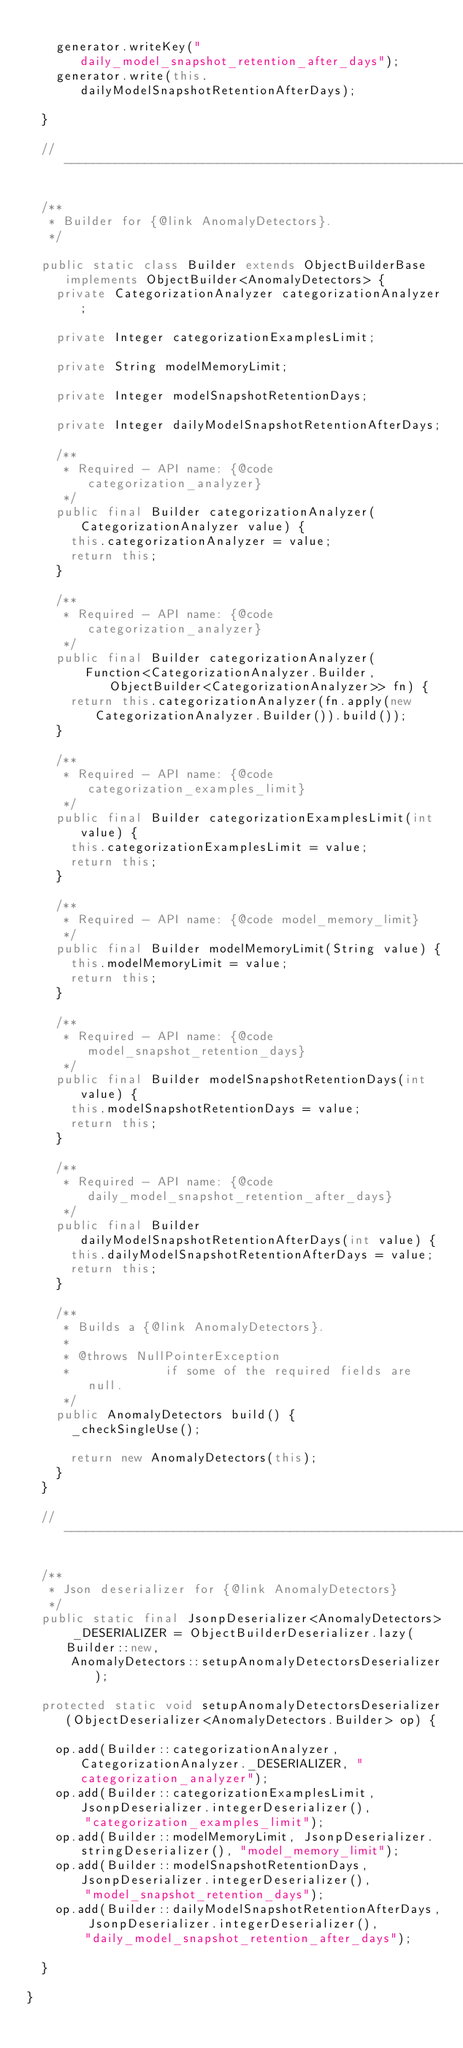<code> <loc_0><loc_0><loc_500><loc_500><_Java_>
		generator.writeKey("daily_model_snapshot_retention_after_days");
		generator.write(this.dailyModelSnapshotRetentionAfterDays);

	}

	// ---------------------------------------------------------------------------------------------

	/**
	 * Builder for {@link AnomalyDetectors}.
	 */

	public static class Builder extends ObjectBuilderBase implements ObjectBuilder<AnomalyDetectors> {
		private CategorizationAnalyzer categorizationAnalyzer;

		private Integer categorizationExamplesLimit;

		private String modelMemoryLimit;

		private Integer modelSnapshotRetentionDays;

		private Integer dailyModelSnapshotRetentionAfterDays;

		/**
		 * Required - API name: {@code categorization_analyzer}
		 */
		public final Builder categorizationAnalyzer(CategorizationAnalyzer value) {
			this.categorizationAnalyzer = value;
			return this;
		}

		/**
		 * Required - API name: {@code categorization_analyzer}
		 */
		public final Builder categorizationAnalyzer(
				Function<CategorizationAnalyzer.Builder, ObjectBuilder<CategorizationAnalyzer>> fn) {
			return this.categorizationAnalyzer(fn.apply(new CategorizationAnalyzer.Builder()).build());
		}

		/**
		 * Required - API name: {@code categorization_examples_limit}
		 */
		public final Builder categorizationExamplesLimit(int value) {
			this.categorizationExamplesLimit = value;
			return this;
		}

		/**
		 * Required - API name: {@code model_memory_limit}
		 */
		public final Builder modelMemoryLimit(String value) {
			this.modelMemoryLimit = value;
			return this;
		}

		/**
		 * Required - API name: {@code model_snapshot_retention_days}
		 */
		public final Builder modelSnapshotRetentionDays(int value) {
			this.modelSnapshotRetentionDays = value;
			return this;
		}

		/**
		 * Required - API name: {@code daily_model_snapshot_retention_after_days}
		 */
		public final Builder dailyModelSnapshotRetentionAfterDays(int value) {
			this.dailyModelSnapshotRetentionAfterDays = value;
			return this;
		}

		/**
		 * Builds a {@link AnomalyDetectors}.
		 *
		 * @throws NullPointerException
		 *             if some of the required fields are null.
		 */
		public AnomalyDetectors build() {
			_checkSingleUse();

			return new AnomalyDetectors(this);
		}
	}

	// ---------------------------------------------------------------------------------------------

	/**
	 * Json deserializer for {@link AnomalyDetectors}
	 */
	public static final JsonpDeserializer<AnomalyDetectors> _DESERIALIZER = ObjectBuilderDeserializer.lazy(Builder::new,
			AnomalyDetectors::setupAnomalyDetectorsDeserializer);

	protected static void setupAnomalyDetectorsDeserializer(ObjectDeserializer<AnomalyDetectors.Builder> op) {

		op.add(Builder::categorizationAnalyzer, CategorizationAnalyzer._DESERIALIZER, "categorization_analyzer");
		op.add(Builder::categorizationExamplesLimit, JsonpDeserializer.integerDeserializer(),
				"categorization_examples_limit");
		op.add(Builder::modelMemoryLimit, JsonpDeserializer.stringDeserializer(), "model_memory_limit");
		op.add(Builder::modelSnapshotRetentionDays, JsonpDeserializer.integerDeserializer(),
				"model_snapshot_retention_days");
		op.add(Builder::dailyModelSnapshotRetentionAfterDays, JsonpDeserializer.integerDeserializer(),
				"daily_model_snapshot_retention_after_days");

	}

}
</code> 